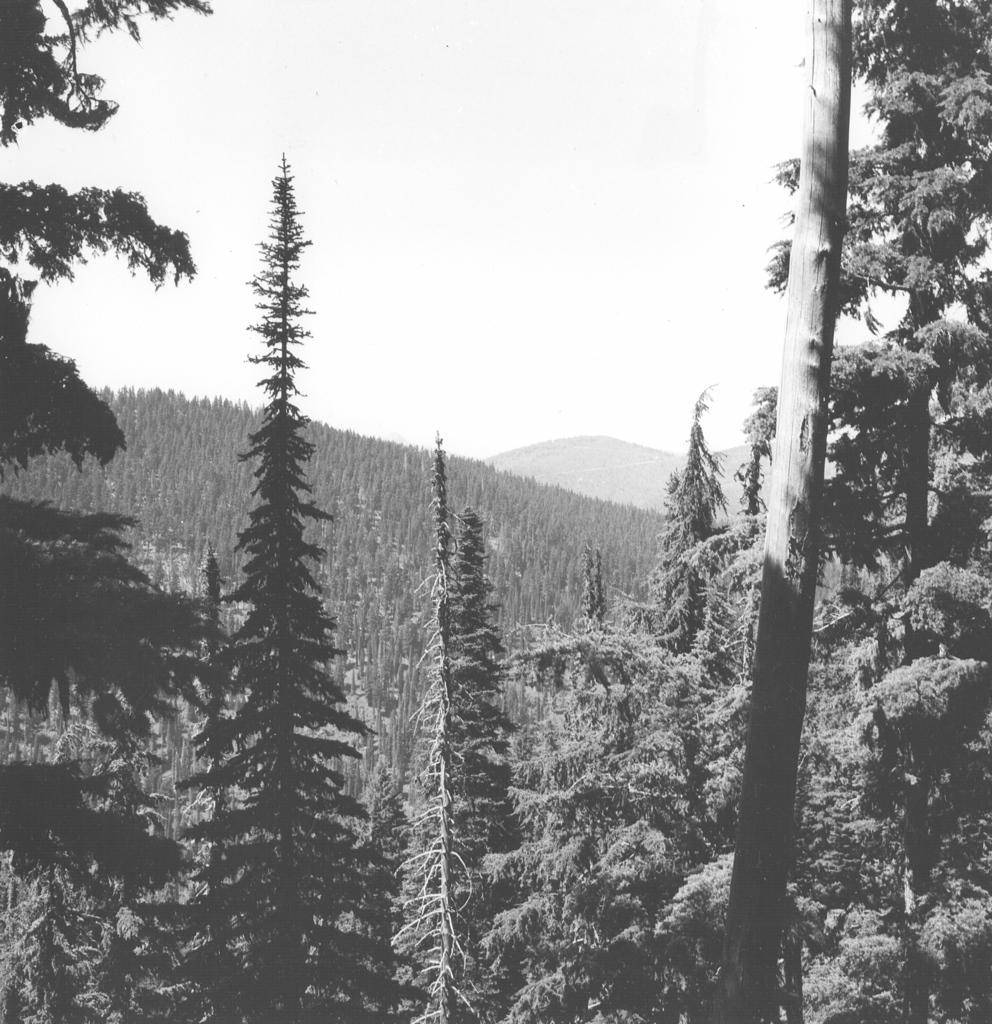What is the color scheme of the image? The image is black and white. What type of natural elements can be seen in the image? There are trees and hills in the image. What part of the sky is visible in the image? The sky is visible in the image. What object is located on the right side of the image? There is a wooden pole on the right side of the image. Are there any fairies flying around the trees in the image? There is no indication of fairies in the image; it only features trees, hills, and a wooden pole. Is there any quicksand visible in the image? There is no quicksand present in the image; it only features trees, hills, and a wooden pole. 